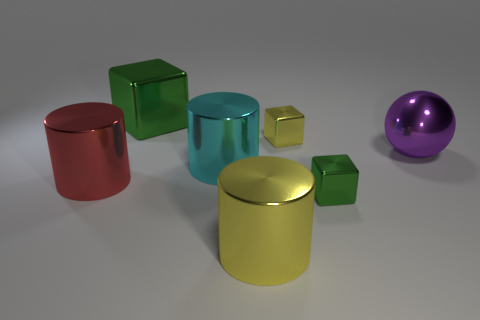How many metal cylinders have the same color as the large ball? 0 